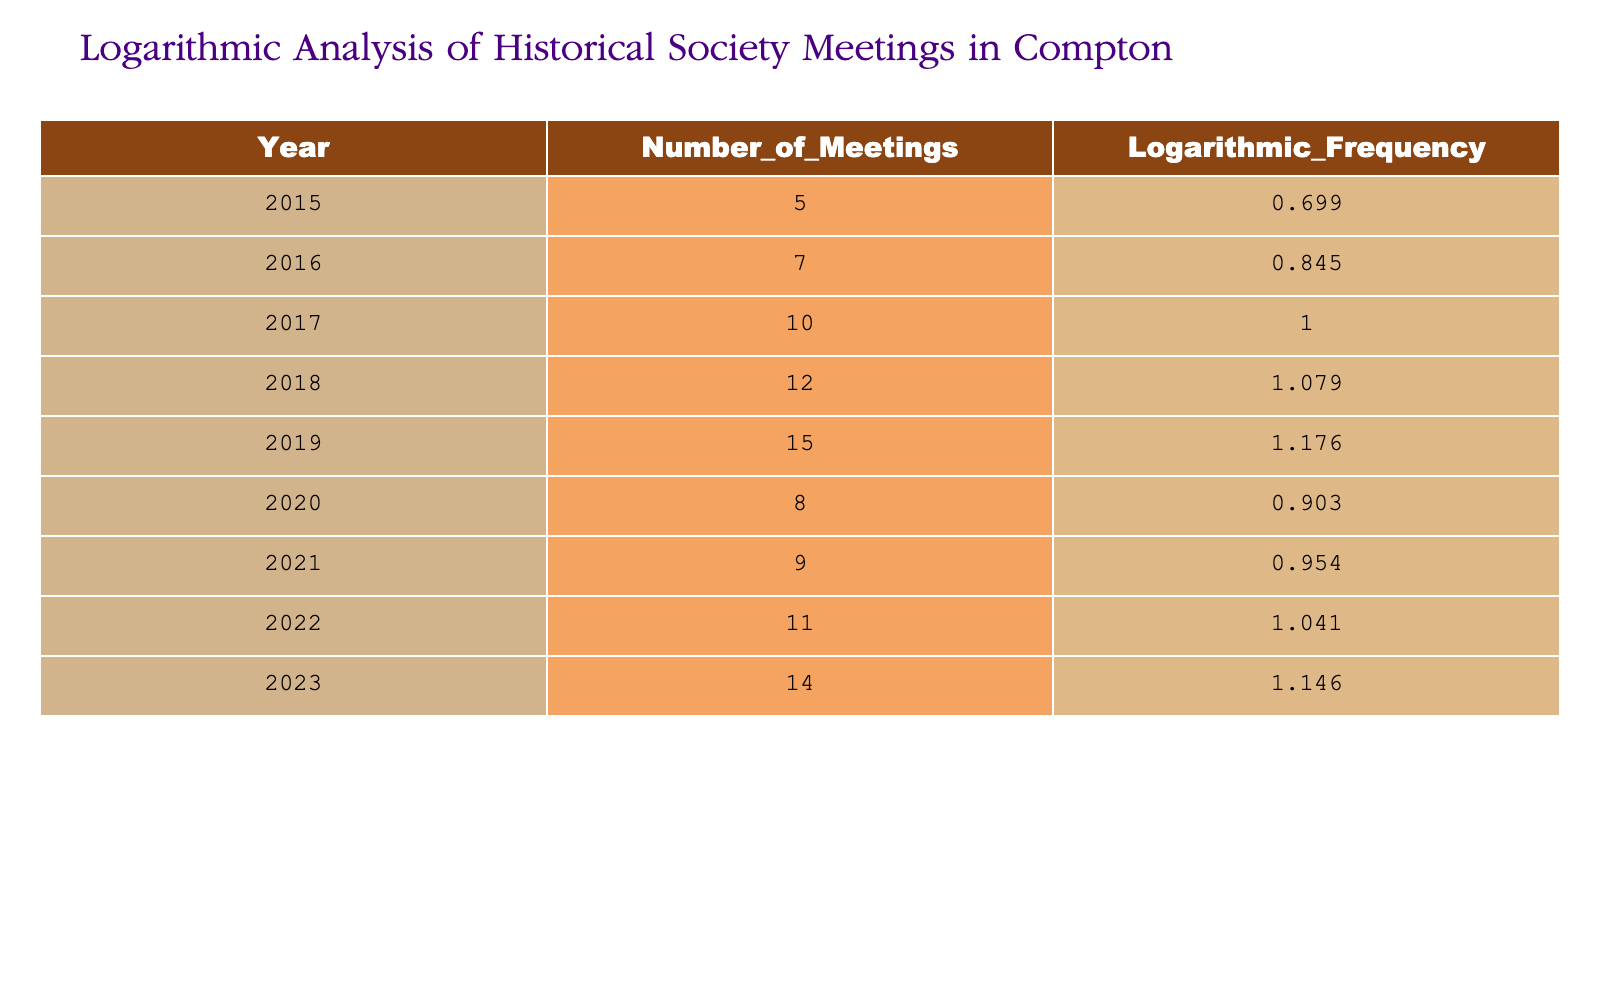What was the total number of meetings held by the historical society from 2015 to 2023? To find the total, we need to add the number of meetings for each year from the table: 5 + 7 + 10 + 12 + 15 + 8 + 9 + 11 + 14 = 81.
Answer: 81 In which year did the historical society have the highest logarithmic frequency of meetings? Reviewing the 'Logarithmic_Frequency' column, the highest value is 1.176, which corresponds to the year 2019.
Answer: 2019 What year had the lowest number of meetings, and how many were there? Looking at the 'Number_of_Meetings' column, the lowest count is 5 in the year 2015.
Answer: 2015, 5 What is the average number of meetings held per year over the entire period? To find the average, we add the total number of meetings (81) and divide by the number of years, which is 9. So, 81/9 = 9.
Answer: 9 Did the number of meetings increase every year from 2015 to 2023? Examining the data, there were fluctuations: the number increased in most years but dropped from 2019 to 2020. Therefore, it did not increase every year.
Answer: No What is the difference in the number of meetings between 2017 and 2021? The number of meetings in 2017 was 10, and in 2021 it was 9. The difference is 10 - 9 = 1.
Answer: 1 In which two consecutive years did the meetings decrease in number? By analyzing the data, it is found that from 2019 (15 meetings) to 2020 (8 meetings) and 2020 to 2021 (9 meetings). Thus, the consecutive decrease occurred only from 2019 to 2020.
Answer: 2019 to 2020 How many years had a logarithmic frequency greater than 1? Looking at the 'Logarithmic_Frequency' column, the years with values greater than 1 are: 2017, 2018, 2019, 2022, and 2023. That's 5 years in total.
Answer: 5 What is the total logarithmic frequency for the years 2018 and 2023? To find this total, we read the 'Logarithmic_Frequency' values for those years: 1.079 (2018) + 1.146 (2023) = 2.225.
Answer: 2.225 